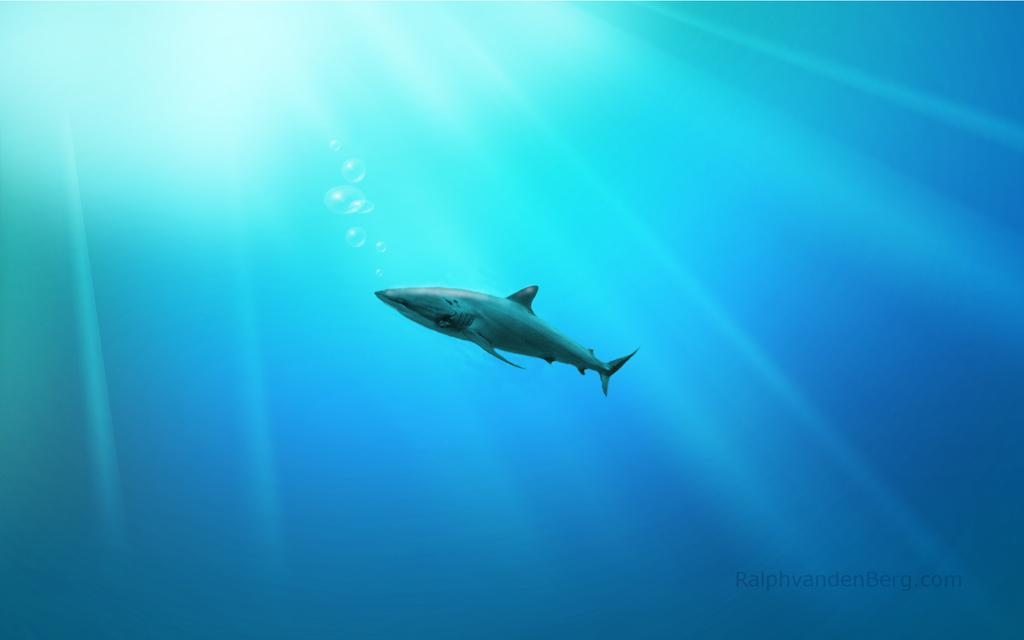What is the primary element in the image? The image consists of water. What can be seen in the middle of the water? There is a shark in the middle of the image. What type of ring can be seen on the shark's fin in the image? There is no ring present on the shark's fin in the image. How does the acoustics of the water affect the shark's movement in the image? The image does not provide information about the acoustics of the water or how it might affect the shark's movement. 